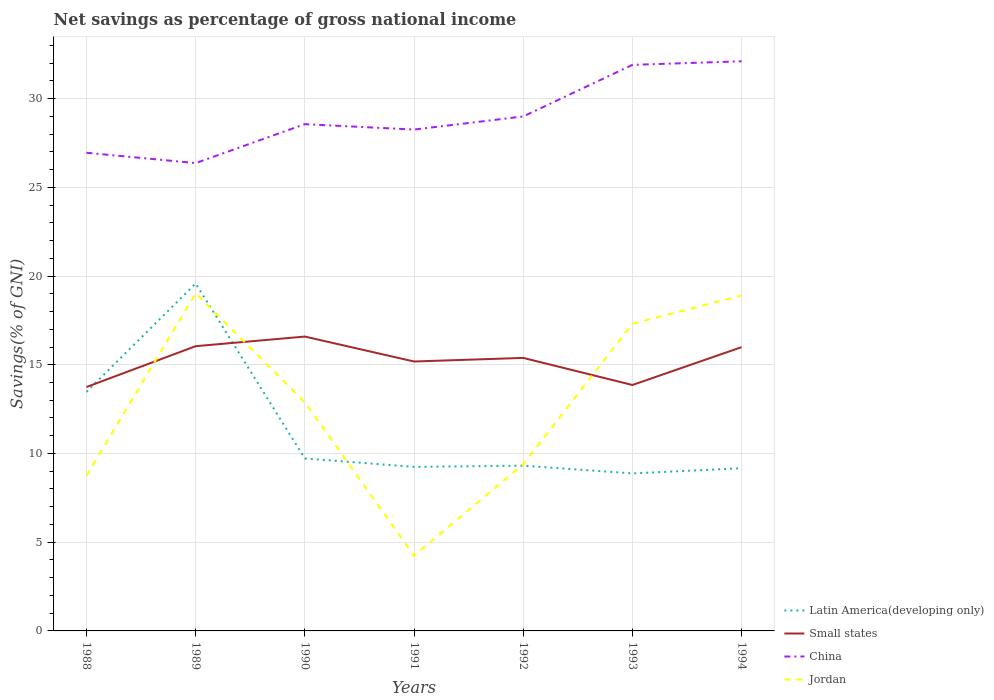How many different coloured lines are there?
Your answer should be compact. 4. Does the line corresponding to China intersect with the line corresponding to Jordan?
Offer a terse response. No. Across all years, what is the maximum total savings in Small states?
Your answer should be very brief. 13.75. What is the total total savings in Jordan in the graph?
Offer a terse response. -4.14. What is the difference between the highest and the second highest total savings in Latin America(developing only)?
Provide a short and direct response. 10.7. How many lines are there?
Give a very brief answer. 4. How many years are there in the graph?
Offer a terse response. 7. What is the difference between two consecutive major ticks on the Y-axis?
Ensure brevity in your answer.  5. Does the graph contain any zero values?
Provide a short and direct response. No. Where does the legend appear in the graph?
Make the answer very short. Bottom right. How many legend labels are there?
Your answer should be very brief. 4. How are the legend labels stacked?
Your answer should be very brief. Vertical. What is the title of the graph?
Your answer should be very brief. Net savings as percentage of gross national income. Does "Marshall Islands" appear as one of the legend labels in the graph?
Keep it short and to the point. No. What is the label or title of the X-axis?
Your response must be concise. Years. What is the label or title of the Y-axis?
Provide a succinct answer. Savings(% of GNI). What is the Savings(% of GNI) in Latin America(developing only) in 1988?
Provide a short and direct response. 13.47. What is the Savings(% of GNI) of Small states in 1988?
Provide a succinct answer. 13.75. What is the Savings(% of GNI) in China in 1988?
Keep it short and to the point. 26.95. What is the Savings(% of GNI) in Jordan in 1988?
Ensure brevity in your answer.  8.75. What is the Savings(% of GNI) in Latin America(developing only) in 1989?
Your answer should be compact. 19.58. What is the Savings(% of GNI) in Small states in 1989?
Your answer should be compact. 16.05. What is the Savings(% of GNI) in China in 1989?
Provide a short and direct response. 26.37. What is the Savings(% of GNI) in Jordan in 1989?
Provide a succinct answer. 19.03. What is the Savings(% of GNI) in Latin America(developing only) in 1990?
Make the answer very short. 9.72. What is the Savings(% of GNI) in Small states in 1990?
Provide a short and direct response. 16.59. What is the Savings(% of GNI) of China in 1990?
Ensure brevity in your answer.  28.56. What is the Savings(% of GNI) in Jordan in 1990?
Your answer should be compact. 12.89. What is the Savings(% of GNI) in Latin America(developing only) in 1991?
Your answer should be compact. 9.24. What is the Savings(% of GNI) in Small states in 1991?
Provide a short and direct response. 15.18. What is the Savings(% of GNI) of China in 1991?
Offer a very short reply. 28.26. What is the Savings(% of GNI) of Jordan in 1991?
Ensure brevity in your answer.  4.24. What is the Savings(% of GNI) in Latin America(developing only) in 1992?
Provide a succinct answer. 9.31. What is the Savings(% of GNI) of Small states in 1992?
Make the answer very short. 15.39. What is the Savings(% of GNI) of China in 1992?
Provide a short and direct response. 28.99. What is the Savings(% of GNI) in Jordan in 1992?
Your answer should be very brief. 9.39. What is the Savings(% of GNI) of Latin America(developing only) in 1993?
Give a very brief answer. 8.88. What is the Savings(% of GNI) of Small states in 1993?
Make the answer very short. 13.86. What is the Savings(% of GNI) in China in 1993?
Offer a very short reply. 31.9. What is the Savings(% of GNI) in Jordan in 1993?
Ensure brevity in your answer.  17.31. What is the Savings(% of GNI) of Latin America(developing only) in 1994?
Provide a succinct answer. 9.17. What is the Savings(% of GNI) in Small states in 1994?
Provide a succinct answer. 15.99. What is the Savings(% of GNI) of China in 1994?
Your response must be concise. 32.1. What is the Savings(% of GNI) in Jordan in 1994?
Your response must be concise. 18.91. Across all years, what is the maximum Savings(% of GNI) in Latin America(developing only)?
Your response must be concise. 19.58. Across all years, what is the maximum Savings(% of GNI) in Small states?
Offer a terse response. 16.59. Across all years, what is the maximum Savings(% of GNI) in China?
Ensure brevity in your answer.  32.1. Across all years, what is the maximum Savings(% of GNI) of Jordan?
Offer a terse response. 19.03. Across all years, what is the minimum Savings(% of GNI) of Latin America(developing only)?
Make the answer very short. 8.88. Across all years, what is the minimum Savings(% of GNI) of Small states?
Your response must be concise. 13.75. Across all years, what is the minimum Savings(% of GNI) in China?
Give a very brief answer. 26.37. Across all years, what is the minimum Savings(% of GNI) of Jordan?
Offer a terse response. 4.24. What is the total Savings(% of GNI) of Latin America(developing only) in the graph?
Your response must be concise. 79.37. What is the total Savings(% of GNI) in Small states in the graph?
Keep it short and to the point. 106.81. What is the total Savings(% of GNI) of China in the graph?
Provide a succinct answer. 203.13. What is the total Savings(% of GNI) in Jordan in the graph?
Offer a very short reply. 90.51. What is the difference between the Savings(% of GNI) of Latin America(developing only) in 1988 and that in 1989?
Provide a short and direct response. -6.11. What is the difference between the Savings(% of GNI) in Small states in 1988 and that in 1989?
Give a very brief answer. -2.3. What is the difference between the Savings(% of GNI) of China in 1988 and that in 1989?
Offer a very short reply. 0.58. What is the difference between the Savings(% of GNI) of Jordan in 1988 and that in 1989?
Give a very brief answer. -10.29. What is the difference between the Savings(% of GNI) in Latin America(developing only) in 1988 and that in 1990?
Provide a succinct answer. 3.75. What is the difference between the Savings(% of GNI) of Small states in 1988 and that in 1990?
Provide a succinct answer. -2.84. What is the difference between the Savings(% of GNI) in China in 1988 and that in 1990?
Your answer should be compact. -1.61. What is the difference between the Savings(% of GNI) in Jordan in 1988 and that in 1990?
Provide a succinct answer. -4.14. What is the difference between the Savings(% of GNI) in Latin America(developing only) in 1988 and that in 1991?
Provide a short and direct response. 4.23. What is the difference between the Savings(% of GNI) of Small states in 1988 and that in 1991?
Offer a terse response. -1.44. What is the difference between the Savings(% of GNI) of China in 1988 and that in 1991?
Offer a very short reply. -1.31. What is the difference between the Savings(% of GNI) in Jordan in 1988 and that in 1991?
Provide a succinct answer. 4.51. What is the difference between the Savings(% of GNI) of Latin America(developing only) in 1988 and that in 1992?
Your answer should be compact. 4.16. What is the difference between the Savings(% of GNI) of Small states in 1988 and that in 1992?
Provide a succinct answer. -1.64. What is the difference between the Savings(% of GNI) in China in 1988 and that in 1992?
Keep it short and to the point. -2.05. What is the difference between the Savings(% of GNI) of Jordan in 1988 and that in 1992?
Provide a succinct answer. -0.65. What is the difference between the Savings(% of GNI) in Latin America(developing only) in 1988 and that in 1993?
Your response must be concise. 4.59. What is the difference between the Savings(% of GNI) of Small states in 1988 and that in 1993?
Keep it short and to the point. -0.11. What is the difference between the Savings(% of GNI) in China in 1988 and that in 1993?
Make the answer very short. -4.95. What is the difference between the Savings(% of GNI) of Jordan in 1988 and that in 1993?
Make the answer very short. -8.57. What is the difference between the Savings(% of GNI) in Latin America(developing only) in 1988 and that in 1994?
Your answer should be very brief. 4.3. What is the difference between the Savings(% of GNI) of Small states in 1988 and that in 1994?
Give a very brief answer. -2.25. What is the difference between the Savings(% of GNI) in China in 1988 and that in 1994?
Your answer should be very brief. -5.15. What is the difference between the Savings(% of GNI) of Jordan in 1988 and that in 1994?
Give a very brief answer. -10.16. What is the difference between the Savings(% of GNI) in Latin America(developing only) in 1989 and that in 1990?
Your response must be concise. 9.86. What is the difference between the Savings(% of GNI) in Small states in 1989 and that in 1990?
Ensure brevity in your answer.  -0.54. What is the difference between the Savings(% of GNI) in China in 1989 and that in 1990?
Ensure brevity in your answer.  -2.19. What is the difference between the Savings(% of GNI) of Jordan in 1989 and that in 1990?
Ensure brevity in your answer.  6.15. What is the difference between the Savings(% of GNI) in Latin America(developing only) in 1989 and that in 1991?
Offer a very short reply. 10.33. What is the difference between the Savings(% of GNI) in Small states in 1989 and that in 1991?
Your response must be concise. 0.86. What is the difference between the Savings(% of GNI) of China in 1989 and that in 1991?
Give a very brief answer. -1.89. What is the difference between the Savings(% of GNI) in Jordan in 1989 and that in 1991?
Give a very brief answer. 14.8. What is the difference between the Savings(% of GNI) of Latin America(developing only) in 1989 and that in 1992?
Keep it short and to the point. 10.27. What is the difference between the Savings(% of GNI) of Small states in 1989 and that in 1992?
Offer a terse response. 0.66. What is the difference between the Savings(% of GNI) in China in 1989 and that in 1992?
Your answer should be very brief. -2.63. What is the difference between the Savings(% of GNI) of Jordan in 1989 and that in 1992?
Offer a terse response. 9.64. What is the difference between the Savings(% of GNI) in Latin America(developing only) in 1989 and that in 1993?
Give a very brief answer. 10.7. What is the difference between the Savings(% of GNI) in Small states in 1989 and that in 1993?
Provide a succinct answer. 2.19. What is the difference between the Savings(% of GNI) of China in 1989 and that in 1993?
Keep it short and to the point. -5.54. What is the difference between the Savings(% of GNI) of Jordan in 1989 and that in 1993?
Ensure brevity in your answer.  1.72. What is the difference between the Savings(% of GNI) of Latin America(developing only) in 1989 and that in 1994?
Provide a succinct answer. 10.41. What is the difference between the Savings(% of GNI) in Small states in 1989 and that in 1994?
Offer a very short reply. 0.05. What is the difference between the Savings(% of GNI) of China in 1989 and that in 1994?
Give a very brief answer. -5.74. What is the difference between the Savings(% of GNI) in Jordan in 1989 and that in 1994?
Your answer should be very brief. 0.13. What is the difference between the Savings(% of GNI) in Latin America(developing only) in 1990 and that in 1991?
Give a very brief answer. 0.48. What is the difference between the Savings(% of GNI) of Small states in 1990 and that in 1991?
Ensure brevity in your answer.  1.41. What is the difference between the Savings(% of GNI) of China in 1990 and that in 1991?
Provide a succinct answer. 0.3. What is the difference between the Savings(% of GNI) in Jordan in 1990 and that in 1991?
Provide a succinct answer. 8.65. What is the difference between the Savings(% of GNI) of Latin America(developing only) in 1990 and that in 1992?
Offer a terse response. 0.41. What is the difference between the Savings(% of GNI) of Small states in 1990 and that in 1992?
Ensure brevity in your answer.  1.2. What is the difference between the Savings(% of GNI) of China in 1990 and that in 1992?
Provide a short and direct response. -0.44. What is the difference between the Savings(% of GNI) in Jordan in 1990 and that in 1992?
Offer a very short reply. 3.49. What is the difference between the Savings(% of GNI) of Latin America(developing only) in 1990 and that in 1993?
Offer a very short reply. 0.84. What is the difference between the Savings(% of GNI) of Small states in 1990 and that in 1993?
Provide a short and direct response. 2.73. What is the difference between the Savings(% of GNI) in China in 1990 and that in 1993?
Your answer should be compact. -3.34. What is the difference between the Savings(% of GNI) in Jordan in 1990 and that in 1993?
Provide a succinct answer. -4.43. What is the difference between the Savings(% of GNI) in Latin America(developing only) in 1990 and that in 1994?
Provide a short and direct response. 0.55. What is the difference between the Savings(% of GNI) in Small states in 1990 and that in 1994?
Your response must be concise. 0.6. What is the difference between the Savings(% of GNI) of China in 1990 and that in 1994?
Keep it short and to the point. -3.54. What is the difference between the Savings(% of GNI) in Jordan in 1990 and that in 1994?
Your answer should be compact. -6.02. What is the difference between the Savings(% of GNI) in Latin America(developing only) in 1991 and that in 1992?
Ensure brevity in your answer.  -0.07. What is the difference between the Savings(% of GNI) in Small states in 1991 and that in 1992?
Your response must be concise. -0.2. What is the difference between the Savings(% of GNI) in China in 1991 and that in 1992?
Your response must be concise. -0.74. What is the difference between the Savings(% of GNI) of Jordan in 1991 and that in 1992?
Give a very brief answer. -5.16. What is the difference between the Savings(% of GNI) of Latin America(developing only) in 1991 and that in 1993?
Provide a succinct answer. 0.37. What is the difference between the Savings(% of GNI) in Small states in 1991 and that in 1993?
Ensure brevity in your answer.  1.32. What is the difference between the Savings(% of GNI) in China in 1991 and that in 1993?
Provide a succinct answer. -3.65. What is the difference between the Savings(% of GNI) of Jordan in 1991 and that in 1993?
Make the answer very short. -13.08. What is the difference between the Savings(% of GNI) of Latin America(developing only) in 1991 and that in 1994?
Your answer should be compact. 0.08. What is the difference between the Savings(% of GNI) of Small states in 1991 and that in 1994?
Offer a terse response. -0.81. What is the difference between the Savings(% of GNI) of China in 1991 and that in 1994?
Offer a very short reply. -3.85. What is the difference between the Savings(% of GNI) of Jordan in 1991 and that in 1994?
Your answer should be very brief. -14.67. What is the difference between the Savings(% of GNI) of Latin America(developing only) in 1992 and that in 1993?
Offer a terse response. 0.43. What is the difference between the Savings(% of GNI) of Small states in 1992 and that in 1993?
Your answer should be very brief. 1.53. What is the difference between the Savings(% of GNI) of China in 1992 and that in 1993?
Your response must be concise. -2.91. What is the difference between the Savings(% of GNI) in Jordan in 1992 and that in 1993?
Provide a short and direct response. -7.92. What is the difference between the Savings(% of GNI) of Latin America(developing only) in 1992 and that in 1994?
Keep it short and to the point. 0.14. What is the difference between the Savings(% of GNI) in Small states in 1992 and that in 1994?
Give a very brief answer. -0.61. What is the difference between the Savings(% of GNI) in China in 1992 and that in 1994?
Make the answer very short. -3.11. What is the difference between the Savings(% of GNI) in Jordan in 1992 and that in 1994?
Provide a short and direct response. -9.51. What is the difference between the Savings(% of GNI) in Latin America(developing only) in 1993 and that in 1994?
Provide a short and direct response. -0.29. What is the difference between the Savings(% of GNI) in Small states in 1993 and that in 1994?
Keep it short and to the point. -2.13. What is the difference between the Savings(% of GNI) in China in 1993 and that in 1994?
Offer a very short reply. -0.2. What is the difference between the Savings(% of GNI) of Jordan in 1993 and that in 1994?
Your answer should be very brief. -1.59. What is the difference between the Savings(% of GNI) of Latin America(developing only) in 1988 and the Savings(% of GNI) of Small states in 1989?
Your answer should be compact. -2.58. What is the difference between the Savings(% of GNI) in Latin America(developing only) in 1988 and the Savings(% of GNI) in China in 1989?
Ensure brevity in your answer.  -12.89. What is the difference between the Savings(% of GNI) in Latin America(developing only) in 1988 and the Savings(% of GNI) in Jordan in 1989?
Your response must be concise. -5.56. What is the difference between the Savings(% of GNI) of Small states in 1988 and the Savings(% of GNI) of China in 1989?
Your answer should be compact. -12.62. What is the difference between the Savings(% of GNI) in Small states in 1988 and the Savings(% of GNI) in Jordan in 1989?
Keep it short and to the point. -5.29. What is the difference between the Savings(% of GNI) of China in 1988 and the Savings(% of GNI) of Jordan in 1989?
Make the answer very short. 7.91. What is the difference between the Savings(% of GNI) of Latin America(developing only) in 1988 and the Savings(% of GNI) of Small states in 1990?
Give a very brief answer. -3.12. What is the difference between the Savings(% of GNI) of Latin America(developing only) in 1988 and the Savings(% of GNI) of China in 1990?
Ensure brevity in your answer.  -15.09. What is the difference between the Savings(% of GNI) in Latin America(developing only) in 1988 and the Savings(% of GNI) in Jordan in 1990?
Offer a very short reply. 0.58. What is the difference between the Savings(% of GNI) in Small states in 1988 and the Savings(% of GNI) in China in 1990?
Ensure brevity in your answer.  -14.81. What is the difference between the Savings(% of GNI) of Small states in 1988 and the Savings(% of GNI) of Jordan in 1990?
Make the answer very short. 0.86. What is the difference between the Savings(% of GNI) of China in 1988 and the Savings(% of GNI) of Jordan in 1990?
Ensure brevity in your answer.  14.06. What is the difference between the Savings(% of GNI) of Latin America(developing only) in 1988 and the Savings(% of GNI) of Small states in 1991?
Provide a succinct answer. -1.71. What is the difference between the Savings(% of GNI) in Latin America(developing only) in 1988 and the Savings(% of GNI) in China in 1991?
Make the answer very short. -14.78. What is the difference between the Savings(% of GNI) of Latin America(developing only) in 1988 and the Savings(% of GNI) of Jordan in 1991?
Give a very brief answer. 9.24. What is the difference between the Savings(% of GNI) in Small states in 1988 and the Savings(% of GNI) in China in 1991?
Provide a succinct answer. -14.51. What is the difference between the Savings(% of GNI) of Small states in 1988 and the Savings(% of GNI) of Jordan in 1991?
Your response must be concise. 9.51. What is the difference between the Savings(% of GNI) of China in 1988 and the Savings(% of GNI) of Jordan in 1991?
Your answer should be very brief. 22.71. What is the difference between the Savings(% of GNI) of Latin America(developing only) in 1988 and the Savings(% of GNI) of Small states in 1992?
Provide a short and direct response. -1.92. What is the difference between the Savings(% of GNI) of Latin America(developing only) in 1988 and the Savings(% of GNI) of China in 1992?
Provide a short and direct response. -15.52. What is the difference between the Savings(% of GNI) in Latin America(developing only) in 1988 and the Savings(% of GNI) in Jordan in 1992?
Ensure brevity in your answer.  4.08. What is the difference between the Savings(% of GNI) of Small states in 1988 and the Savings(% of GNI) of China in 1992?
Give a very brief answer. -15.25. What is the difference between the Savings(% of GNI) in Small states in 1988 and the Savings(% of GNI) in Jordan in 1992?
Make the answer very short. 4.35. What is the difference between the Savings(% of GNI) of China in 1988 and the Savings(% of GNI) of Jordan in 1992?
Provide a short and direct response. 17.56. What is the difference between the Savings(% of GNI) of Latin America(developing only) in 1988 and the Savings(% of GNI) of Small states in 1993?
Offer a very short reply. -0.39. What is the difference between the Savings(% of GNI) of Latin America(developing only) in 1988 and the Savings(% of GNI) of China in 1993?
Give a very brief answer. -18.43. What is the difference between the Savings(% of GNI) of Latin America(developing only) in 1988 and the Savings(% of GNI) of Jordan in 1993?
Offer a terse response. -3.84. What is the difference between the Savings(% of GNI) in Small states in 1988 and the Savings(% of GNI) in China in 1993?
Make the answer very short. -18.16. What is the difference between the Savings(% of GNI) in Small states in 1988 and the Savings(% of GNI) in Jordan in 1993?
Your answer should be very brief. -3.57. What is the difference between the Savings(% of GNI) in China in 1988 and the Savings(% of GNI) in Jordan in 1993?
Ensure brevity in your answer.  9.64. What is the difference between the Savings(% of GNI) in Latin America(developing only) in 1988 and the Savings(% of GNI) in Small states in 1994?
Your answer should be compact. -2.52. What is the difference between the Savings(% of GNI) in Latin America(developing only) in 1988 and the Savings(% of GNI) in China in 1994?
Ensure brevity in your answer.  -18.63. What is the difference between the Savings(% of GNI) in Latin America(developing only) in 1988 and the Savings(% of GNI) in Jordan in 1994?
Your answer should be compact. -5.43. What is the difference between the Savings(% of GNI) in Small states in 1988 and the Savings(% of GNI) in China in 1994?
Give a very brief answer. -18.36. What is the difference between the Savings(% of GNI) in Small states in 1988 and the Savings(% of GNI) in Jordan in 1994?
Make the answer very short. -5.16. What is the difference between the Savings(% of GNI) of China in 1988 and the Savings(% of GNI) of Jordan in 1994?
Offer a very short reply. 8.04. What is the difference between the Savings(% of GNI) of Latin America(developing only) in 1989 and the Savings(% of GNI) of Small states in 1990?
Your response must be concise. 2.99. What is the difference between the Savings(% of GNI) of Latin America(developing only) in 1989 and the Savings(% of GNI) of China in 1990?
Your response must be concise. -8.98. What is the difference between the Savings(% of GNI) of Latin America(developing only) in 1989 and the Savings(% of GNI) of Jordan in 1990?
Keep it short and to the point. 6.69. What is the difference between the Savings(% of GNI) of Small states in 1989 and the Savings(% of GNI) of China in 1990?
Provide a short and direct response. -12.51. What is the difference between the Savings(% of GNI) of Small states in 1989 and the Savings(% of GNI) of Jordan in 1990?
Your response must be concise. 3.16. What is the difference between the Savings(% of GNI) of China in 1989 and the Savings(% of GNI) of Jordan in 1990?
Give a very brief answer. 13.48. What is the difference between the Savings(% of GNI) of Latin America(developing only) in 1989 and the Savings(% of GNI) of Small states in 1991?
Ensure brevity in your answer.  4.4. What is the difference between the Savings(% of GNI) of Latin America(developing only) in 1989 and the Savings(% of GNI) of China in 1991?
Ensure brevity in your answer.  -8.68. What is the difference between the Savings(% of GNI) in Latin America(developing only) in 1989 and the Savings(% of GNI) in Jordan in 1991?
Ensure brevity in your answer.  15.34. What is the difference between the Savings(% of GNI) in Small states in 1989 and the Savings(% of GNI) in China in 1991?
Your response must be concise. -12.21. What is the difference between the Savings(% of GNI) in Small states in 1989 and the Savings(% of GNI) in Jordan in 1991?
Your answer should be compact. 11.81. What is the difference between the Savings(% of GNI) in China in 1989 and the Savings(% of GNI) in Jordan in 1991?
Your answer should be very brief. 22.13. What is the difference between the Savings(% of GNI) of Latin America(developing only) in 1989 and the Savings(% of GNI) of Small states in 1992?
Keep it short and to the point. 4.19. What is the difference between the Savings(% of GNI) of Latin America(developing only) in 1989 and the Savings(% of GNI) of China in 1992?
Your response must be concise. -9.42. What is the difference between the Savings(% of GNI) of Latin America(developing only) in 1989 and the Savings(% of GNI) of Jordan in 1992?
Offer a very short reply. 10.19. What is the difference between the Savings(% of GNI) of Small states in 1989 and the Savings(% of GNI) of China in 1992?
Ensure brevity in your answer.  -12.95. What is the difference between the Savings(% of GNI) of Small states in 1989 and the Savings(% of GNI) of Jordan in 1992?
Ensure brevity in your answer.  6.66. What is the difference between the Savings(% of GNI) of China in 1989 and the Savings(% of GNI) of Jordan in 1992?
Your answer should be very brief. 16.97. What is the difference between the Savings(% of GNI) of Latin America(developing only) in 1989 and the Savings(% of GNI) of Small states in 1993?
Make the answer very short. 5.72. What is the difference between the Savings(% of GNI) of Latin America(developing only) in 1989 and the Savings(% of GNI) of China in 1993?
Your answer should be very brief. -12.32. What is the difference between the Savings(% of GNI) of Latin America(developing only) in 1989 and the Savings(% of GNI) of Jordan in 1993?
Offer a very short reply. 2.27. What is the difference between the Savings(% of GNI) of Small states in 1989 and the Savings(% of GNI) of China in 1993?
Offer a very short reply. -15.85. What is the difference between the Savings(% of GNI) in Small states in 1989 and the Savings(% of GNI) in Jordan in 1993?
Your answer should be very brief. -1.26. What is the difference between the Savings(% of GNI) of China in 1989 and the Savings(% of GNI) of Jordan in 1993?
Offer a very short reply. 9.05. What is the difference between the Savings(% of GNI) of Latin America(developing only) in 1989 and the Savings(% of GNI) of Small states in 1994?
Offer a terse response. 3.59. What is the difference between the Savings(% of GNI) in Latin America(developing only) in 1989 and the Savings(% of GNI) in China in 1994?
Your response must be concise. -12.52. What is the difference between the Savings(% of GNI) in Latin America(developing only) in 1989 and the Savings(% of GNI) in Jordan in 1994?
Provide a short and direct response. 0.67. What is the difference between the Savings(% of GNI) of Small states in 1989 and the Savings(% of GNI) of China in 1994?
Keep it short and to the point. -16.05. What is the difference between the Savings(% of GNI) of Small states in 1989 and the Savings(% of GNI) of Jordan in 1994?
Offer a terse response. -2.86. What is the difference between the Savings(% of GNI) in China in 1989 and the Savings(% of GNI) in Jordan in 1994?
Offer a very short reply. 7.46. What is the difference between the Savings(% of GNI) in Latin America(developing only) in 1990 and the Savings(% of GNI) in Small states in 1991?
Offer a very short reply. -5.46. What is the difference between the Savings(% of GNI) of Latin America(developing only) in 1990 and the Savings(% of GNI) of China in 1991?
Make the answer very short. -18.53. What is the difference between the Savings(% of GNI) of Latin America(developing only) in 1990 and the Savings(% of GNI) of Jordan in 1991?
Ensure brevity in your answer.  5.48. What is the difference between the Savings(% of GNI) of Small states in 1990 and the Savings(% of GNI) of China in 1991?
Make the answer very short. -11.67. What is the difference between the Savings(% of GNI) of Small states in 1990 and the Savings(% of GNI) of Jordan in 1991?
Offer a very short reply. 12.35. What is the difference between the Savings(% of GNI) of China in 1990 and the Savings(% of GNI) of Jordan in 1991?
Provide a short and direct response. 24.32. What is the difference between the Savings(% of GNI) of Latin America(developing only) in 1990 and the Savings(% of GNI) of Small states in 1992?
Your response must be concise. -5.67. What is the difference between the Savings(% of GNI) of Latin America(developing only) in 1990 and the Savings(% of GNI) of China in 1992?
Make the answer very short. -19.27. What is the difference between the Savings(% of GNI) in Latin America(developing only) in 1990 and the Savings(% of GNI) in Jordan in 1992?
Offer a very short reply. 0.33. What is the difference between the Savings(% of GNI) in Small states in 1990 and the Savings(% of GNI) in China in 1992?
Provide a short and direct response. -12.41. What is the difference between the Savings(% of GNI) in Small states in 1990 and the Savings(% of GNI) in Jordan in 1992?
Ensure brevity in your answer.  7.2. What is the difference between the Savings(% of GNI) of China in 1990 and the Savings(% of GNI) of Jordan in 1992?
Keep it short and to the point. 19.17. What is the difference between the Savings(% of GNI) in Latin America(developing only) in 1990 and the Savings(% of GNI) in Small states in 1993?
Ensure brevity in your answer.  -4.14. What is the difference between the Savings(% of GNI) of Latin America(developing only) in 1990 and the Savings(% of GNI) of China in 1993?
Offer a terse response. -22.18. What is the difference between the Savings(% of GNI) of Latin America(developing only) in 1990 and the Savings(% of GNI) of Jordan in 1993?
Ensure brevity in your answer.  -7.59. What is the difference between the Savings(% of GNI) of Small states in 1990 and the Savings(% of GNI) of China in 1993?
Offer a very short reply. -15.31. What is the difference between the Savings(% of GNI) in Small states in 1990 and the Savings(% of GNI) in Jordan in 1993?
Your response must be concise. -0.72. What is the difference between the Savings(% of GNI) of China in 1990 and the Savings(% of GNI) of Jordan in 1993?
Offer a very short reply. 11.25. What is the difference between the Savings(% of GNI) of Latin America(developing only) in 1990 and the Savings(% of GNI) of Small states in 1994?
Your answer should be very brief. -6.27. What is the difference between the Savings(% of GNI) of Latin America(developing only) in 1990 and the Savings(% of GNI) of China in 1994?
Offer a terse response. -22.38. What is the difference between the Savings(% of GNI) in Latin America(developing only) in 1990 and the Savings(% of GNI) in Jordan in 1994?
Make the answer very short. -9.18. What is the difference between the Savings(% of GNI) in Small states in 1990 and the Savings(% of GNI) in China in 1994?
Make the answer very short. -15.51. What is the difference between the Savings(% of GNI) in Small states in 1990 and the Savings(% of GNI) in Jordan in 1994?
Ensure brevity in your answer.  -2.32. What is the difference between the Savings(% of GNI) of China in 1990 and the Savings(% of GNI) of Jordan in 1994?
Your response must be concise. 9.65. What is the difference between the Savings(% of GNI) of Latin America(developing only) in 1991 and the Savings(% of GNI) of Small states in 1992?
Keep it short and to the point. -6.14. What is the difference between the Savings(% of GNI) of Latin America(developing only) in 1991 and the Savings(% of GNI) of China in 1992?
Keep it short and to the point. -19.75. What is the difference between the Savings(% of GNI) of Latin America(developing only) in 1991 and the Savings(% of GNI) of Jordan in 1992?
Give a very brief answer. -0.15. What is the difference between the Savings(% of GNI) of Small states in 1991 and the Savings(% of GNI) of China in 1992?
Offer a very short reply. -13.81. What is the difference between the Savings(% of GNI) in Small states in 1991 and the Savings(% of GNI) in Jordan in 1992?
Offer a very short reply. 5.79. What is the difference between the Savings(% of GNI) of China in 1991 and the Savings(% of GNI) of Jordan in 1992?
Provide a succinct answer. 18.86. What is the difference between the Savings(% of GNI) of Latin America(developing only) in 1991 and the Savings(% of GNI) of Small states in 1993?
Give a very brief answer. -4.62. What is the difference between the Savings(% of GNI) in Latin America(developing only) in 1991 and the Savings(% of GNI) in China in 1993?
Ensure brevity in your answer.  -22.66. What is the difference between the Savings(% of GNI) in Latin America(developing only) in 1991 and the Savings(% of GNI) in Jordan in 1993?
Your response must be concise. -8.07. What is the difference between the Savings(% of GNI) of Small states in 1991 and the Savings(% of GNI) of China in 1993?
Give a very brief answer. -16.72. What is the difference between the Savings(% of GNI) in Small states in 1991 and the Savings(% of GNI) in Jordan in 1993?
Your answer should be very brief. -2.13. What is the difference between the Savings(% of GNI) in China in 1991 and the Savings(% of GNI) in Jordan in 1993?
Offer a very short reply. 10.94. What is the difference between the Savings(% of GNI) in Latin America(developing only) in 1991 and the Savings(% of GNI) in Small states in 1994?
Make the answer very short. -6.75. What is the difference between the Savings(% of GNI) of Latin America(developing only) in 1991 and the Savings(% of GNI) of China in 1994?
Provide a succinct answer. -22.86. What is the difference between the Savings(% of GNI) in Latin America(developing only) in 1991 and the Savings(% of GNI) in Jordan in 1994?
Your answer should be very brief. -9.66. What is the difference between the Savings(% of GNI) of Small states in 1991 and the Savings(% of GNI) of China in 1994?
Your response must be concise. -16.92. What is the difference between the Savings(% of GNI) of Small states in 1991 and the Savings(% of GNI) of Jordan in 1994?
Make the answer very short. -3.72. What is the difference between the Savings(% of GNI) in China in 1991 and the Savings(% of GNI) in Jordan in 1994?
Give a very brief answer. 9.35. What is the difference between the Savings(% of GNI) of Latin America(developing only) in 1992 and the Savings(% of GNI) of Small states in 1993?
Provide a succinct answer. -4.55. What is the difference between the Savings(% of GNI) of Latin America(developing only) in 1992 and the Savings(% of GNI) of China in 1993?
Keep it short and to the point. -22.59. What is the difference between the Savings(% of GNI) in Latin America(developing only) in 1992 and the Savings(% of GNI) in Jordan in 1993?
Give a very brief answer. -8. What is the difference between the Savings(% of GNI) in Small states in 1992 and the Savings(% of GNI) in China in 1993?
Offer a very short reply. -16.52. What is the difference between the Savings(% of GNI) in Small states in 1992 and the Savings(% of GNI) in Jordan in 1993?
Offer a terse response. -1.93. What is the difference between the Savings(% of GNI) in China in 1992 and the Savings(% of GNI) in Jordan in 1993?
Keep it short and to the point. 11.68. What is the difference between the Savings(% of GNI) in Latin America(developing only) in 1992 and the Savings(% of GNI) in Small states in 1994?
Your answer should be very brief. -6.68. What is the difference between the Savings(% of GNI) in Latin America(developing only) in 1992 and the Savings(% of GNI) in China in 1994?
Provide a short and direct response. -22.79. What is the difference between the Savings(% of GNI) of Latin America(developing only) in 1992 and the Savings(% of GNI) of Jordan in 1994?
Your answer should be compact. -9.59. What is the difference between the Savings(% of GNI) in Small states in 1992 and the Savings(% of GNI) in China in 1994?
Provide a short and direct response. -16.72. What is the difference between the Savings(% of GNI) in Small states in 1992 and the Savings(% of GNI) in Jordan in 1994?
Make the answer very short. -3.52. What is the difference between the Savings(% of GNI) of China in 1992 and the Savings(% of GNI) of Jordan in 1994?
Offer a terse response. 10.09. What is the difference between the Savings(% of GNI) in Latin America(developing only) in 1993 and the Savings(% of GNI) in Small states in 1994?
Give a very brief answer. -7.12. What is the difference between the Savings(% of GNI) of Latin America(developing only) in 1993 and the Savings(% of GNI) of China in 1994?
Your answer should be very brief. -23.22. What is the difference between the Savings(% of GNI) in Latin America(developing only) in 1993 and the Savings(% of GNI) in Jordan in 1994?
Offer a terse response. -10.03. What is the difference between the Savings(% of GNI) in Small states in 1993 and the Savings(% of GNI) in China in 1994?
Offer a very short reply. -18.24. What is the difference between the Savings(% of GNI) in Small states in 1993 and the Savings(% of GNI) in Jordan in 1994?
Your answer should be very brief. -5.05. What is the difference between the Savings(% of GNI) of China in 1993 and the Savings(% of GNI) of Jordan in 1994?
Your answer should be compact. 13. What is the average Savings(% of GNI) in Latin America(developing only) per year?
Offer a very short reply. 11.34. What is the average Savings(% of GNI) in Small states per year?
Your response must be concise. 15.26. What is the average Savings(% of GNI) in China per year?
Provide a succinct answer. 29.02. What is the average Savings(% of GNI) of Jordan per year?
Give a very brief answer. 12.93. In the year 1988, what is the difference between the Savings(% of GNI) in Latin America(developing only) and Savings(% of GNI) in Small states?
Give a very brief answer. -0.28. In the year 1988, what is the difference between the Savings(% of GNI) of Latin America(developing only) and Savings(% of GNI) of China?
Offer a very short reply. -13.48. In the year 1988, what is the difference between the Savings(% of GNI) of Latin America(developing only) and Savings(% of GNI) of Jordan?
Give a very brief answer. 4.72. In the year 1988, what is the difference between the Savings(% of GNI) in Small states and Savings(% of GNI) in China?
Provide a short and direct response. -13.2. In the year 1988, what is the difference between the Savings(% of GNI) in Small states and Savings(% of GNI) in Jordan?
Your answer should be compact. 5. In the year 1988, what is the difference between the Savings(% of GNI) of China and Savings(% of GNI) of Jordan?
Give a very brief answer. 18.2. In the year 1989, what is the difference between the Savings(% of GNI) of Latin America(developing only) and Savings(% of GNI) of Small states?
Give a very brief answer. 3.53. In the year 1989, what is the difference between the Savings(% of GNI) of Latin America(developing only) and Savings(% of GNI) of China?
Provide a succinct answer. -6.79. In the year 1989, what is the difference between the Savings(% of GNI) in Latin America(developing only) and Savings(% of GNI) in Jordan?
Make the answer very short. 0.54. In the year 1989, what is the difference between the Savings(% of GNI) in Small states and Savings(% of GNI) in China?
Make the answer very short. -10.32. In the year 1989, what is the difference between the Savings(% of GNI) in Small states and Savings(% of GNI) in Jordan?
Your answer should be very brief. -2.99. In the year 1989, what is the difference between the Savings(% of GNI) in China and Savings(% of GNI) in Jordan?
Your response must be concise. 7.33. In the year 1990, what is the difference between the Savings(% of GNI) of Latin America(developing only) and Savings(% of GNI) of Small states?
Offer a terse response. -6.87. In the year 1990, what is the difference between the Savings(% of GNI) of Latin America(developing only) and Savings(% of GNI) of China?
Your answer should be compact. -18.84. In the year 1990, what is the difference between the Savings(% of GNI) in Latin America(developing only) and Savings(% of GNI) in Jordan?
Provide a short and direct response. -3.17. In the year 1990, what is the difference between the Savings(% of GNI) of Small states and Savings(% of GNI) of China?
Offer a terse response. -11.97. In the year 1990, what is the difference between the Savings(% of GNI) in Small states and Savings(% of GNI) in Jordan?
Give a very brief answer. 3.7. In the year 1990, what is the difference between the Savings(% of GNI) of China and Savings(% of GNI) of Jordan?
Provide a short and direct response. 15.67. In the year 1991, what is the difference between the Savings(% of GNI) in Latin America(developing only) and Savings(% of GNI) in Small states?
Provide a succinct answer. -5.94. In the year 1991, what is the difference between the Savings(% of GNI) of Latin America(developing only) and Savings(% of GNI) of China?
Your answer should be compact. -19.01. In the year 1991, what is the difference between the Savings(% of GNI) in Latin America(developing only) and Savings(% of GNI) in Jordan?
Offer a very short reply. 5.01. In the year 1991, what is the difference between the Savings(% of GNI) of Small states and Savings(% of GNI) of China?
Provide a succinct answer. -13.07. In the year 1991, what is the difference between the Savings(% of GNI) of Small states and Savings(% of GNI) of Jordan?
Ensure brevity in your answer.  10.95. In the year 1991, what is the difference between the Savings(% of GNI) in China and Savings(% of GNI) in Jordan?
Offer a very short reply. 24.02. In the year 1992, what is the difference between the Savings(% of GNI) in Latin America(developing only) and Savings(% of GNI) in Small states?
Ensure brevity in your answer.  -6.08. In the year 1992, what is the difference between the Savings(% of GNI) in Latin America(developing only) and Savings(% of GNI) in China?
Make the answer very short. -19.68. In the year 1992, what is the difference between the Savings(% of GNI) of Latin America(developing only) and Savings(% of GNI) of Jordan?
Give a very brief answer. -0.08. In the year 1992, what is the difference between the Savings(% of GNI) of Small states and Savings(% of GNI) of China?
Your answer should be very brief. -13.61. In the year 1992, what is the difference between the Savings(% of GNI) of Small states and Savings(% of GNI) of Jordan?
Ensure brevity in your answer.  5.99. In the year 1992, what is the difference between the Savings(% of GNI) in China and Savings(% of GNI) in Jordan?
Provide a succinct answer. 19.6. In the year 1993, what is the difference between the Savings(% of GNI) in Latin America(developing only) and Savings(% of GNI) in Small states?
Offer a terse response. -4.98. In the year 1993, what is the difference between the Savings(% of GNI) in Latin America(developing only) and Savings(% of GNI) in China?
Your answer should be compact. -23.02. In the year 1993, what is the difference between the Savings(% of GNI) in Latin America(developing only) and Savings(% of GNI) in Jordan?
Your answer should be very brief. -8.43. In the year 1993, what is the difference between the Savings(% of GNI) of Small states and Savings(% of GNI) of China?
Make the answer very short. -18.04. In the year 1993, what is the difference between the Savings(% of GNI) in Small states and Savings(% of GNI) in Jordan?
Your answer should be very brief. -3.45. In the year 1993, what is the difference between the Savings(% of GNI) in China and Savings(% of GNI) in Jordan?
Make the answer very short. 14.59. In the year 1994, what is the difference between the Savings(% of GNI) of Latin America(developing only) and Savings(% of GNI) of Small states?
Keep it short and to the point. -6.83. In the year 1994, what is the difference between the Savings(% of GNI) in Latin America(developing only) and Savings(% of GNI) in China?
Offer a terse response. -22.93. In the year 1994, what is the difference between the Savings(% of GNI) of Latin America(developing only) and Savings(% of GNI) of Jordan?
Offer a very short reply. -9.74. In the year 1994, what is the difference between the Savings(% of GNI) of Small states and Savings(% of GNI) of China?
Your answer should be very brief. -16.11. In the year 1994, what is the difference between the Savings(% of GNI) of Small states and Savings(% of GNI) of Jordan?
Keep it short and to the point. -2.91. In the year 1994, what is the difference between the Savings(% of GNI) of China and Savings(% of GNI) of Jordan?
Offer a terse response. 13.2. What is the ratio of the Savings(% of GNI) of Latin America(developing only) in 1988 to that in 1989?
Give a very brief answer. 0.69. What is the ratio of the Savings(% of GNI) of Small states in 1988 to that in 1989?
Give a very brief answer. 0.86. What is the ratio of the Savings(% of GNI) in China in 1988 to that in 1989?
Give a very brief answer. 1.02. What is the ratio of the Savings(% of GNI) in Jordan in 1988 to that in 1989?
Ensure brevity in your answer.  0.46. What is the ratio of the Savings(% of GNI) in Latin America(developing only) in 1988 to that in 1990?
Provide a succinct answer. 1.39. What is the ratio of the Savings(% of GNI) in Small states in 1988 to that in 1990?
Make the answer very short. 0.83. What is the ratio of the Savings(% of GNI) of China in 1988 to that in 1990?
Your response must be concise. 0.94. What is the ratio of the Savings(% of GNI) in Jordan in 1988 to that in 1990?
Provide a succinct answer. 0.68. What is the ratio of the Savings(% of GNI) of Latin America(developing only) in 1988 to that in 1991?
Your answer should be very brief. 1.46. What is the ratio of the Savings(% of GNI) of Small states in 1988 to that in 1991?
Your answer should be compact. 0.91. What is the ratio of the Savings(% of GNI) in China in 1988 to that in 1991?
Give a very brief answer. 0.95. What is the ratio of the Savings(% of GNI) in Jordan in 1988 to that in 1991?
Ensure brevity in your answer.  2.06. What is the ratio of the Savings(% of GNI) of Latin America(developing only) in 1988 to that in 1992?
Offer a terse response. 1.45. What is the ratio of the Savings(% of GNI) in Small states in 1988 to that in 1992?
Keep it short and to the point. 0.89. What is the ratio of the Savings(% of GNI) in China in 1988 to that in 1992?
Ensure brevity in your answer.  0.93. What is the ratio of the Savings(% of GNI) in Jordan in 1988 to that in 1992?
Your answer should be very brief. 0.93. What is the ratio of the Savings(% of GNI) in Latin America(developing only) in 1988 to that in 1993?
Offer a very short reply. 1.52. What is the ratio of the Savings(% of GNI) in Small states in 1988 to that in 1993?
Offer a very short reply. 0.99. What is the ratio of the Savings(% of GNI) in China in 1988 to that in 1993?
Ensure brevity in your answer.  0.84. What is the ratio of the Savings(% of GNI) of Jordan in 1988 to that in 1993?
Your answer should be compact. 0.51. What is the ratio of the Savings(% of GNI) of Latin America(developing only) in 1988 to that in 1994?
Your answer should be very brief. 1.47. What is the ratio of the Savings(% of GNI) in Small states in 1988 to that in 1994?
Give a very brief answer. 0.86. What is the ratio of the Savings(% of GNI) of China in 1988 to that in 1994?
Your response must be concise. 0.84. What is the ratio of the Savings(% of GNI) of Jordan in 1988 to that in 1994?
Offer a terse response. 0.46. What is the ratio of the Savings(% of GNI) in Latin America(developing only) in 1989 to that in 1990?
Make the answer very short. 2.01. What is the ratio of the Savings(% of GNI) of Small states in 1989 to that in 1990?
Ensure brevity in your answer.  0.97. What is the ratio of the Savings(% of GNI) of China in 1989 to that in 1990?
Give a very brief answer. 0.92. What is the ratio of the Savings(% of GNI) of Jordan in 1989 to that in 1990?
Your answer should be compact. 1.48. What is the ratio of the Savings(% of GNI) in Latin America(developing only) in 1989 to that in 1991?
Make the answer very short. 2.12. What is the ratio of the Savings(% of GNI) of Small states in 1989 to that in 1991?
Your answer should be very brief. 1.06. What is the ratio of the Savings(% of GNI) in China in 1989 to that in 1991?
Keep it short and to the point. 0.93. What is the ratio of the Savings(% of GNI) in Jordan in 1989 to that in 1991?
Keep it short and to the point. 4.49. What is the ratio of the Savings(% of GNI) of Latin America(developing only) in 1989 to that in 1992?
Provide a succinct answer. 2.1. What is the ratio of the Savings(% of GNI) of Small states in 1989 to that in 1992?
Provide a short and direct response. 1.04. What is the ratio of the Savings(% of GNI) in China in 1989 to that in 1992?
Your answer should be very brief. 0.91. What is the ratio of the Savings(% of GNI) in Jordan in 1989 to that in 1992?
Keep it short and to the point. 2.03. What is the ratio of the Savings(% of GNI) in Latin America(developing only) in 1989 to that in 1993?
Offer a terse response. 2.21. What is the ratio of the Savings(% of GNI) in Small states in 1989 to that in 1993?
Your answer should be compact. 1.16. What is the ratio of the Savings(% of GNI) in China in 1989 to that in 1993?
Your answer should be very brief. 0.83. What is the ratio of the Savings(% of GNI) of Jordan in 1989 to that in 1993?
Keep it short and to the point. 1.1. What is the ratio of the Savings(% of GNI) of Latin America(developing only) in 1989 to that in 1994?
Offer a very short reply. 2.14. What is the ratio of the Savings(% of GNI) in Small states in 1989 to that in 1994?
Your answer should be very brief. 1. What is the ratio of the Savings(% of GNI) of China in 1989 to that in 1994?
Your response must be concise. 0.82. What is the ratio of the Savings(% of GNI) of Jordan in 1989 to that in 1994?
Make the answer very short. 1.01. What is the ratio of the Savings(% of GNI) in Latin America(developing only) in 1990 to that in 1991?
Your answer should be very brief. 1.05. What is the ratio of the Savings(% of GNI) of Small states in 1990 to that in 1991?
Make the answer very short. 1.09. What is the ratio of the Savings(% of GNI) in China in 1990 to that in 1991?
Give a very brief answer. 1.01. What is the ratio of the Savings(% of GNI) in Jordan in 1990 to that in 1991?
Give a very brief answer. 3.04. What is the ratio of the Savings(% of GNI) in Latin America(developing only) in 1990 to that in 1992?
Provide a short and direct response. 1.04. What is the ratio of the Savings(% of GNI) in Small states in 1990 to that in 1992?
Ensure brevity in your answer.  1.08. What is the ratio of the Savings(% of GNI) of China in 1990 to that in 1992?
Offer a very short reply. 0.98. What is the ratio of the Savings(% of GNI) of Jordan in 1990 to that in 1992?
Give a very brief answer. 1.37. What is the ratio of the Savings(% of GNI) in Latin America(developing only) in 1990 to that in 1993?
Your response must be concise. 1.09. What is the ratio of the Savings(% of GNI) in Small states in 1990 to that in 1993?
Provide a short and direct response. 1.2. What is the ratio of the Savings(% of GNI) in China in 1990 to that in 1993?
Give a very brief answer. 0.9. What is the ratio of the Savings(% of GNI) in Jordan in 1990 to that in 1993?
Offer a terse response. 0.74. What is the ratio of the Savings(% of GNI) of Latin America(developing only) in 1990 to that in 1994?
Your answer should be very brief. 1.06. What is the ratio of the Savings(% of GNI) in Small states in 1990 to that in 1994?
Ensure brevity in your answer.  1.04. What is the ratio of the Savings(% of GNI) in China in 1990 to that in 1994?
Provide a succinct answer. 0.89. What is the ratio of the Savings(% of GNI) in Jordan in 1990 to that in 1994?
Your response must be concise. 0.68. What is the ratio of the Savings(% of GNI) of China in 1991 to that in 1992?
Offer a very short reply. 0.97. What is the ratio of the Savings(% of GNI) of Jordan in 1991 to that in 1992?
Your answer should be compact. 0.45. What is the ratio of the Savings(% of GNI) of Latin America(developing only) in 1991 to that in 1993?
Give a very brief answer. 1.04. What is the ratio of the Savings(% of GNI) in Small states in 1991 to that in 1993?
Offer a terse response. 1.1. What is the ratio of the Savings(% of GNI) in China in 1991 to that in 1993?
Your response must be concise. 0.89. What is the ratio of the Savings(% of GNI) of Jordan in 1991 to that in 1993?
Keep it short and to the point. 0.24. What is the ratio of the Savings(% of GNI) in Latin America(developing only) in 1991 to that in 1994?
Give a very brief answer. 1.01. What is the ratio of the Savings(% of GNI) of Small states in 1991 to that in 1994?
Keep it short and to the point. 0.95. What is the ratio of the Savings(% of GNI) of China in 1991 to that in 1994?
Provide a short and direct response. 0.88. What is the ratio of the Savings(% of GNI) in Jordan in 1991 to that in 1994?
Your answer should be very brief. 0.22. What is the ratio of the Savings(% of GNI) in Latin America(developing only) in 1992 to that in 1993?
Provide a succinct answer. 1.05. What is the ratio of the Savings(% of GNI) of Small states in 1992 to that in 1993?
Offer a terse response. 1.11. What is the ratio of the Savings(% of GNI) of China in 1992 to that in 1993?
Your answer should be compact. 0.91. What is the ratio of the Savings(% of GNI) in Jordan in 1992 to that in 1993?
Provide a succinct answer. 0.54. What is the ratio of the Savings(% of GNI) of Latin America(developing only) in 1992 to that in 1994?
Keep it short and to the point. 1.02. What is the ratio of the Savings(% of GNI) of Small states in 1992 to that in 1994?
Keep it short and to the point. 0.96. What is the ratio of the Savings(% of GNI) in China in 1992 to that in 1994?
Offer a terse response. 0.9. What is the ratio of the Savings(% of GNI) of Jordan in 1992 to that in 1994?
Your response must be concise. 0.5. What is the ratio of the Savings(% of GNI) of Latin America(developing only) in 1993 to that in 1994?
Offer a terse response. 0.97. What is the ratio of the Savings(% of GNI) in Small states in 1993 to that in 1994?
Provide a short and direct response. 0.87. What is the ratio of the Savings(% of GNI) of Jordan in 1993 to that in 1994?
Provide a short and direct response. 0.92. What is the difference between the highest and the second highest Savings(% of GNI) in Latin America(developing only)?
Give a very brief answer. 6.11. What is the difference between the highest and the second highest Savings(% of GNI) in Small states?
Offer a very short reply. 0.54. What is the difference between the highest and the second highest Savings(% of GNI) of China?
Offer a very short reply. 0.2. What is the difference between the highest and the second highest Savings(% of GNI) of Jordan?
Provide a short and direct response. 0.13. What is the difference between the highest and the lowest Savings(% of GNI) of Latin America(developing only)?
Make the answer very short. 10.7. What is the difference between the highest and the lowest Savings(% of GNI) of Small states?
Your response must be concise. 2.84. What is the difference between the highest and the lowest Savings(% of GNI) in China?
Provide a succinct answer. 5.74. What is the difference between the highest and the lowest Savings(% of GNI) in Jordan?
Give a very brief answer. 14.8. 